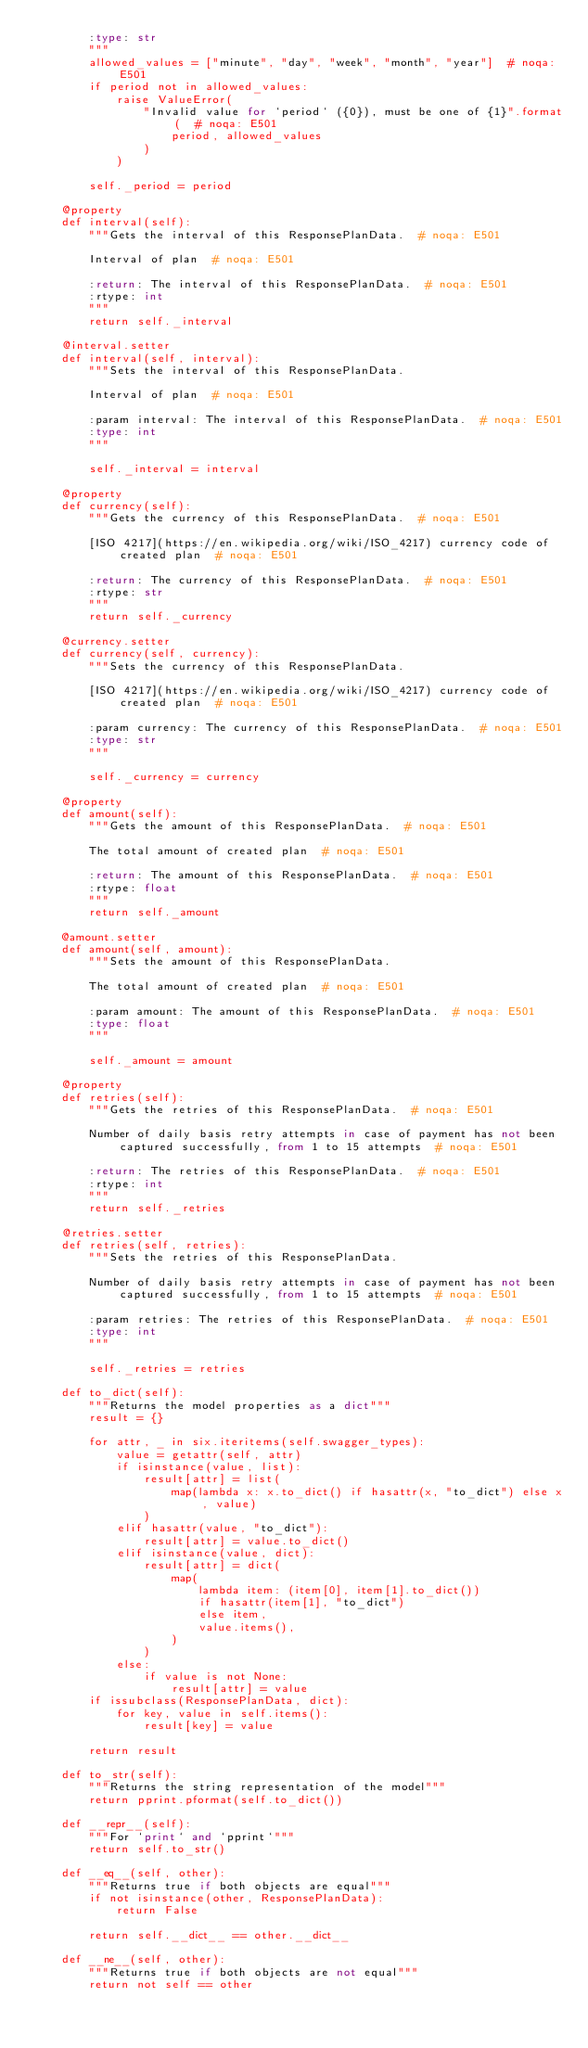<code> <loc_0><loc_0><loc_500><loc_500><_Python_>        :type: str
        """
        allowed_values = ["minute", "day", "week", "month", "year"]  # noqa: E501
        if period not in allowed_values:
            raise ValueError(
                "Invalid value for `period` ({0}), must be one of {1}".format(  # noqa: E501
                    period, allowed_values
                )
            )

        self._period = period

    @property
    def interval(self):
        """Gets the interval of this ResponsePlanData.  # noqa: E501

        Interval of plan  # noqa: E501

        :return: The interval of this ResponsePlanData.  # noqa: E501
        :rtype: int
        """
        return self._interval

    @interval.setter
    def interval(self, interval):
        """Sets the interval of this ResponsePlanData.

        Interval of plan  # noqa: E501

        :param interval: The interval of this ResponsePlanData.  # noqa: E501
        :type: int
        """

        self._interval = interval

    @property
    def currency(self):
        """Gets the currency of this ResponsePlanData.  # noqa: E501

        [ISO 4217](https://en.wikipedia.org/wiki/ISO_4217) currency code of created plan  # noqa: E501

        :return: The currency of this ResponsePlanData.  # noqa: E501
        :rtype: str
        """
        return self._currency

    @currency.setter
    def currency(self, currency):
        """Sets the currency of this ResponsePlanData.

        [ISO 4217](https://en.wikipedia.org/wiki/ISO_4217) currency code of created plan  # noqa: E501

        :param currency: The currency of this ResponsePlanData.  # noqa: E501
        :type: str
        """

        self._currency = currency

    @property
    def amount(self):
        """Gets the amount of this ResponsePlanData.  # noqa: E501

        The total amount of created plan  # noqa: E501

        :return: The amount of this ResponsePlanData.  # noqa: E501
        :rtype: float
        """
        return self._amount

    @amount.setter
    def amount(self, amount):
        """Sets the amount of this ResponsePlanData.

        The total amount of created plan  # noqa: E501

        :param amount: The amount of this ResponsePlanData.  # noqa: E501
        :type: float
        """

        self._amount = amount

    @property
    def retries(self):
        """Gets the retries of this ResponsePlanData.  # noqa: E501

        Number of daily basis retry attempts in case of payment has not been captured successfully, from 1 to 15 attempts  # noqa: E501

        :return: The retries of this ResponsePlanData.  # noqa: E501
        :rtype: int
        """
        return self._retries

    @retries.setter
    def retries(self, retries):
        """Sets the retries of this ResponsePlanData.

        Number of daily basis retry attempts in case of payment has not been captured successfully, from 1 to 15 attempts  # noqa: E501

        :param retries: The retries of this ResponsePlanData.  # noqa: E501
        :type: int
        """

        self._retries = retries

    def to_dict(self):
        """Returns the model properties as a dict"""
        result = {}

        for attr, _ in six.iteritems(self.swagger_types):
            value = getattr(self, attr)
            if isinstance(value, list):
                result[attr] = list(
                    map(lambda x: x.to_dict() if hasattr(x, "to_dict") else x, value)
                )
            elif hasattr(value, "to_dict"):
                result[attr] = value.to_dict()
            elif isinstance(value, dict):
                result[attr] = dict(
                    map(
                        lambda item: (item[0], item[1].to_dict())
                        if hasattr(item[1], "to_dict")
                        else item,
                        value.items(),
                    )
                )
            else:
                if value is not None:
                    result[attr] = value
        if issubclass(ResponsePlanData, dict):
            for key, value in self.items():
                result[key] = value

        return result

    def to_str(self):
        """Returns the string representation of the model"""
        return pprint.pformat(self.to_dict())

    def __repr__(self):
        """For `print` and `pprint`"""
        return self.to_str()

    def __eq__(self, other):
        """Returns true if both objects are equal"""
        if not isinstance(other, ResponsePlanData):
            return False

        return self.__dict__ == other.__dict__

    def __ne__(self, other):
        """Returns true if both objects are not equal"""
        return not self == other
</code> 